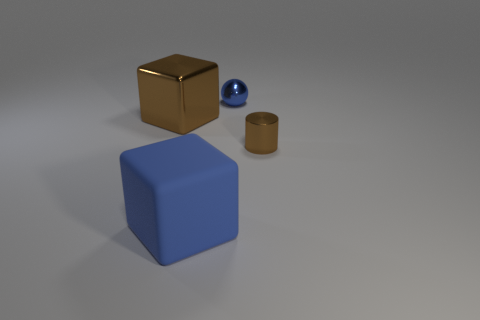What are the colors of the objects in the image? The objects in the image consist of a blue cube, a brown cube, a smaller brown cylinder, and a small blue sphere. Could you describe the arrangement of these objects? Certainly! The brown cube and the blue cube are positioned parallel to each other with some space in between. The small blue sphere is located in front of the blue cube, and the brown cylinder is closer to the foreground, but aligned with the brown cube. 